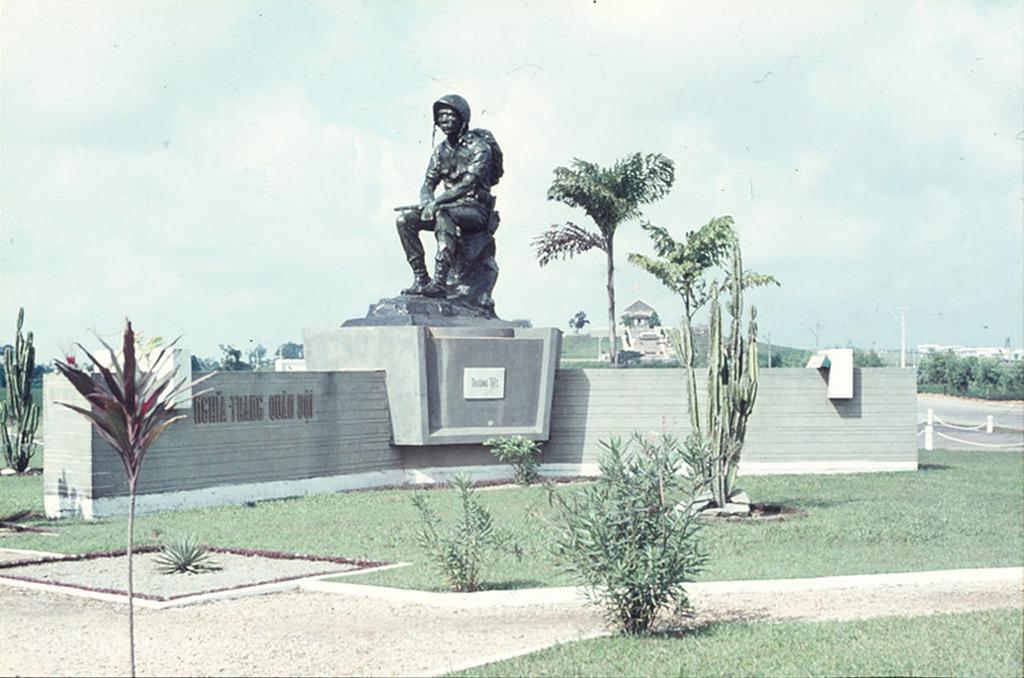How would you summarize this image in a sentence or two? As we can see in the image there are plants, grass, trees, statue. In the background there are buildings. On the top there is sky. 